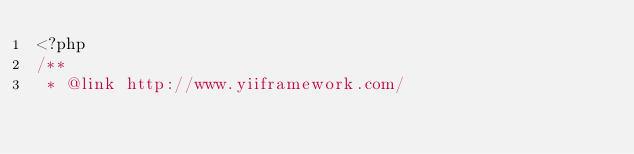<code> <loc_0><loc_0><loc_500><loc_500><_PHP_><?php
/**
 * @link http://www.yiiframework.com/</code> 